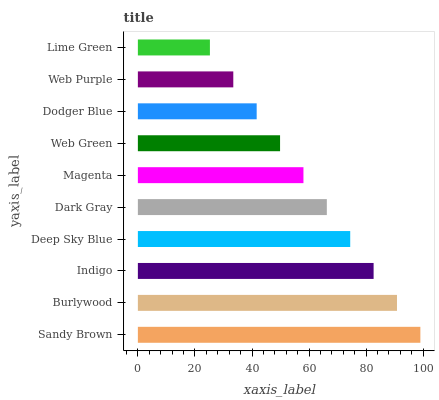Is Lime Green the minimum?
Answer yes or no. Yes. Is Sandy Brown the maximum?
Answer yes or no. Yes. Is Burlywood the minimum?
Answer yes or no. No. Is Burlywood the maximum?
Answer yes or no. No. Is Sandy Brown greater than Burlywood?
Answer yes or no. Yes. Is Burlywood less than Sandy Brown?
Answer yes or no. Yes. Is Burlywood greater than Sandy Brown?
Answer yes or no. No. Is Sandy Brown less than Burlywood?
Answer yes or no. No. Is Dark Gray the high median?
Answer yes or no. Yes. Is Magenta the low median?
Answer yes or no. Yes. Is Dodger Blue the high median?
Answer yes or no. No. Is Burlywood the low median?
Answer yes or no. No. 